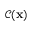Convert formula to latex. <formula><loc_0><loc_0><loc_500><loc_500>\mathcal { C } ( { x } )</formula> 